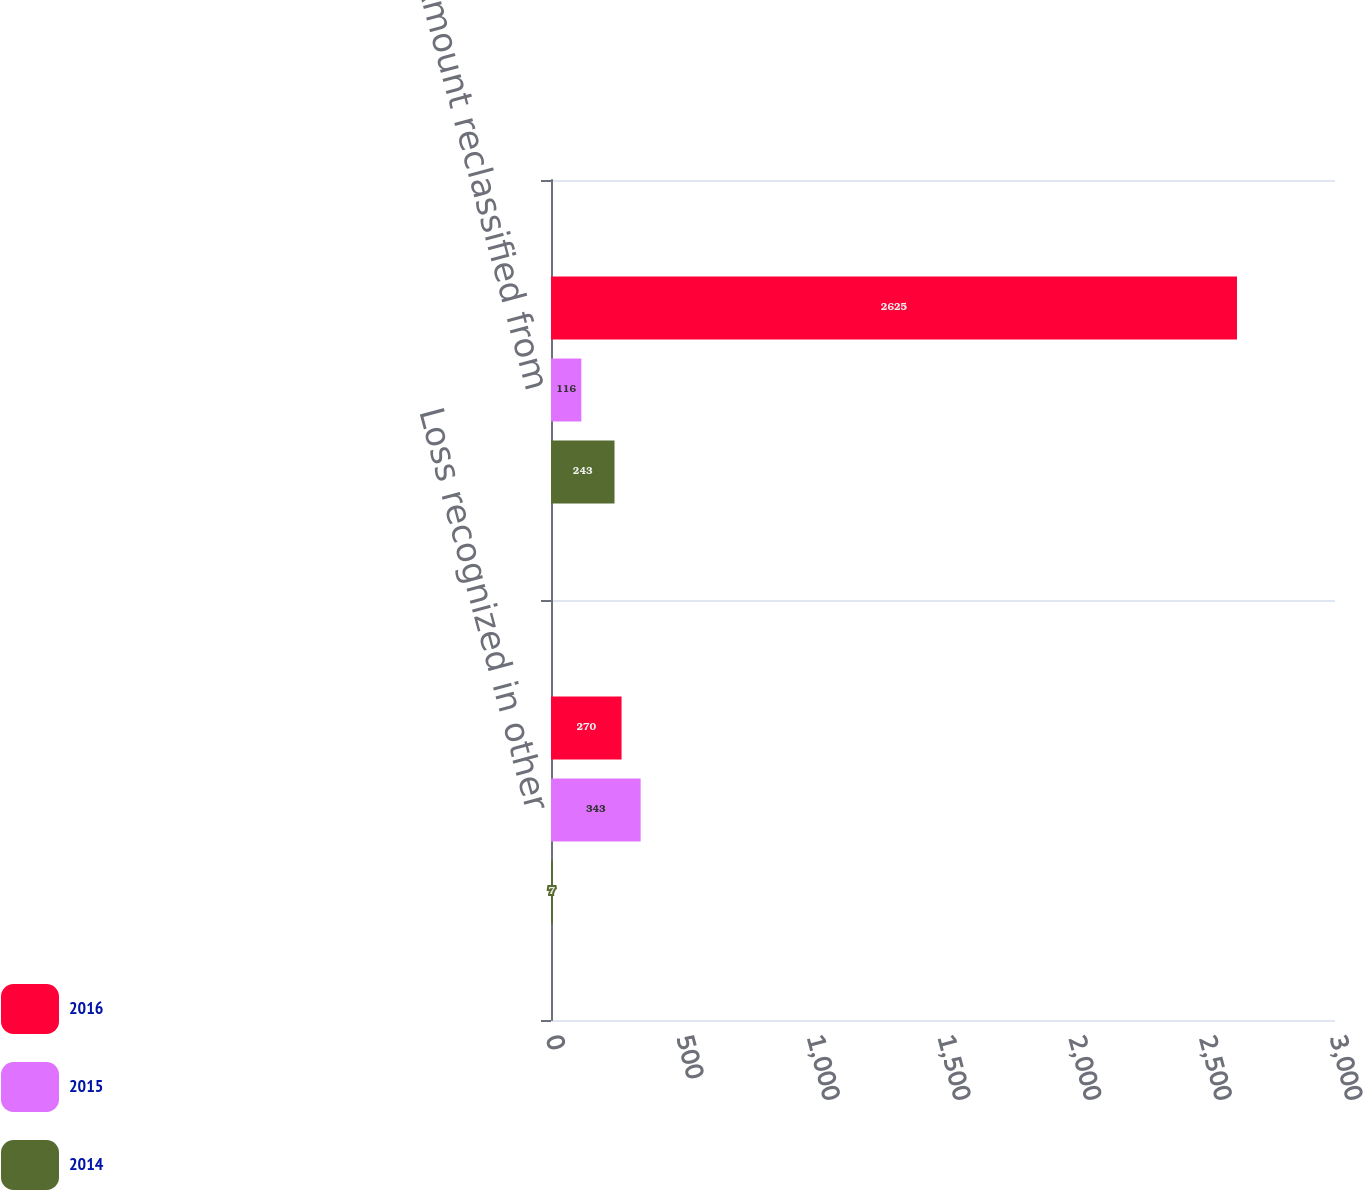Convert chart. <chart><loc_0><loc_0><loc_500><loc_500><stacked_bar_chart><ecel><fcel>Loss recognized in other<fcel>Amount reclassified from<nl><fcel>2016<fcel>270<fcel>2625<nl><fcel>2015<fcel>343<fcel>116<nl><fcel>2014<fcel>7<fcel>243<nl></chart> 